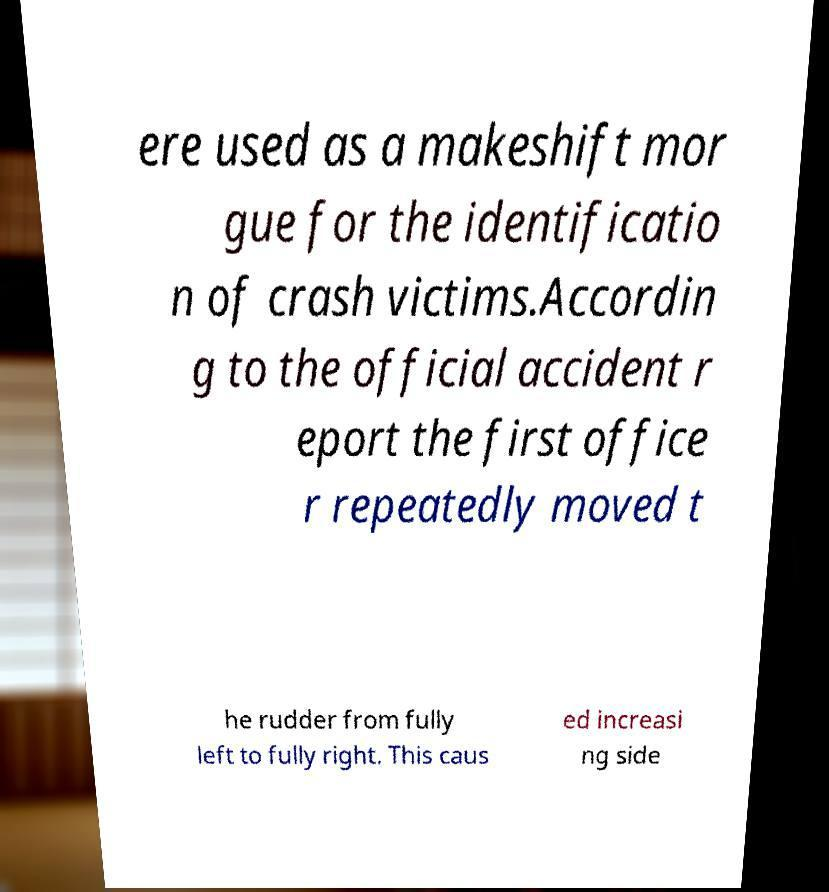What messages or text are displayed in this image? I need them in a readable, typed format. ere used as a makeshift mor gue for the identificatio n of crash victims.Accordin g to the official accident r eport the first office r repeatedly moved t he rudder from fully left to fully right. This caus ed increasi ng side 